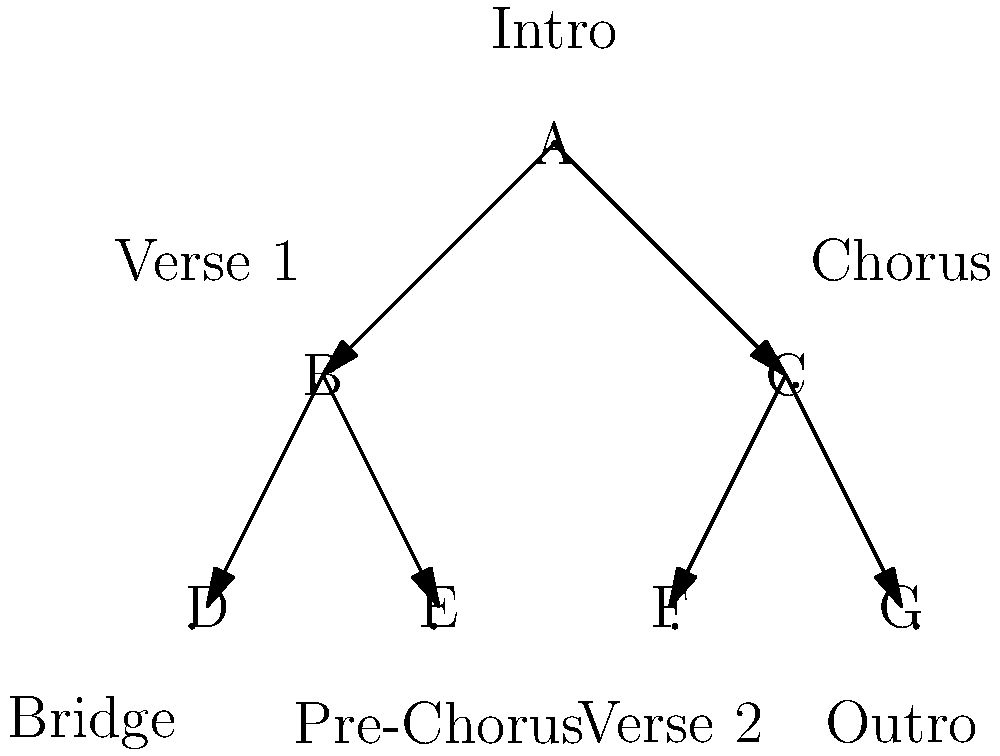In the given tree diagram representing the musical form of a composition, which section (node) has the highest number of direct connections to other sections, and what musical function might this suggest? To answer this question, we need to analyze the tree diagram and follow these steps:

1. Count the number of direct connections (edges) for each node:
   - Node A (Intro): 2 connections
   - Node B (Verse 1): 3 connections (1 incoming, 2 outgoing)
   - Node C (Chorus): 3 connections (1 incoming, 2 outgoing)
   - Nodes D, E, F, G: 1 connection each (only incoming)

2. Identify the node(s) with the highest number of connections:
   Both Node B (Verse 1) and Node C (Chorus) have the highest number of direct connections, with 3 each.

3. Interpret the musical function:
   In this case, Node A (Intro) connects to both B and C, suggesting that it serves as a starting point that leads into either the verse or the chorus. This structure implies that Node A (Intro) is the root of the composition, acting as a central hub from which the song's main sections branch out.

4. Consider the musical implications:
   Having multiple connections suggests that these sections (Verse 1 and Chorus) play pivotal roles in the song's structure. They serve as key transitional points, allowing the composition to flow between different parts of the song. This structure provides flexibility in the arrangement and allows for various pathways through the composition.

In the context of musical form, this arrangement suggests a composition with a clear introductory section that can lead directly into either a verse or a chorus, providing multiple options for the song's development and allowing for a dynamic and varied structure.
Answer: Nodes B (Verse 1) and C (Chorus); central transitional sections 